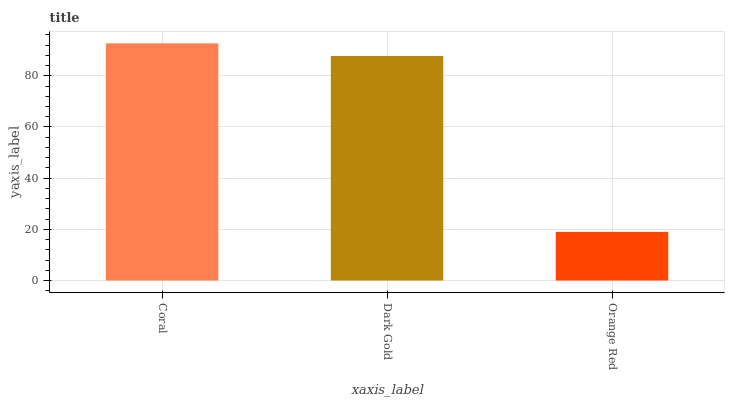Is Orange Red the minimum?
Answer yes or no. Yes. Is Coral the maximum?
Answer yes or no. Yes. Is Dark Gold the minimum?
Answer yes or no. No. Is Dark Gold the maximum?
Answer yes or no. No. Is Coral greater than Dark Gold?
Answer yes or no. Yes. Is Dark Gold less than Coral?
Answer yes or no. Yes. Is Dark Gold greater than Coral?
Answer yes or no. No. Is Coral less than Dark Gold?
Answer yes or no. No. Is Dark Gold the high median?
Answer yes or no. Yes. Is Dark Gold the low median?
Answer yes or no. Yes. Is Coral the high median?
Answer yes or no. No. Is Orange Red the low median?
Answer yes or no. No. 